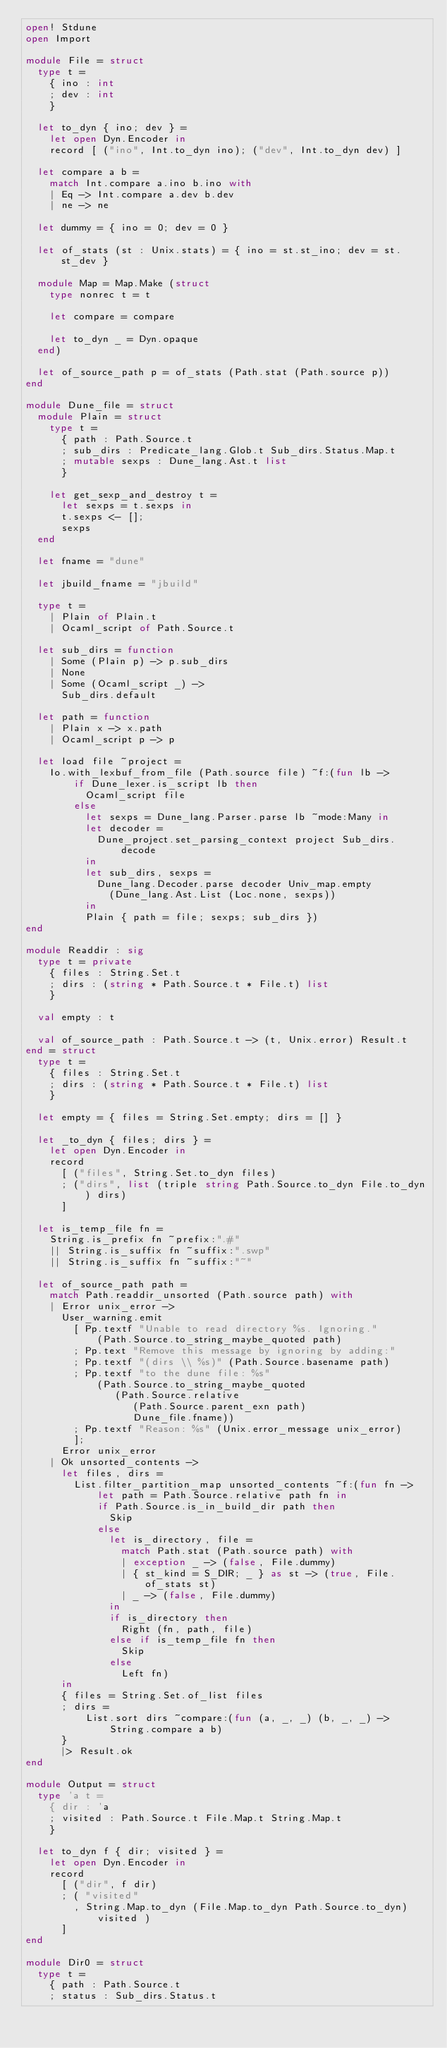<code> <loc_0><loc_0><loc_500><loc_500><_OCaml_>open! Stdune
open Import

module File = struct
  type t =
    { ino : int
    ; dev : int
    }

  let to_dyn { ino; dev } =
    let open Dyn.Encoder in
    record [ ("ino", Int.to_dyn ino); ("dev", Int.to_dyn dev) ]

  let compare a b =
    match Int.compare a.ino b.ino with
    | Eq -> Int.compare a.dev b.dev
    | ne -> ne

  let dummy = { ino = 0; dev = 0 }

  let of_stats (st : Unix.stats) = { ino = st.st_ino; dev = st.st_dev }

  module Map = Map.Make (struct
    type nonrec t = t

    let compare = compare

    let to_dyn _ = Dyn.opaque
  end)

  let of_source_path p = of_stats (Path.stat (Path.source p))
end

module Dune_file = struct
  module Plain = struct
    type t =
      { path : Path.Source.t
      ; sub_dirs : Predicate_lang.Glob.t Sub_dirs.Status.Map.t
      ; mutable sexps : Dune_lang.Ast.t list
      }

    let get_sexp_and_destroy t =
      let sexps = t.sexps in
      t.sexps <- [];
      sexps
  end

  let fname = "dune"

  let jbuild_fname = "jbuild"

  type t =
    | Plain of Plain.t
    | Ocaml_script of Path.Source.t

  let sub_dirs = function
    | Some (Plain p) -> p.sub_dirs
    | None
    | Some (Ocaml_script _) ->
      Sub_dirs.default

  let path = function
    | Plain x -> x.path
    | Ocaml_script p -> p

  let load file ~project =
    Io.with_lexbuf_from_file (Path.source file) ~f:(fun lb ->
        if Dune_lexer.is_script lb then
          Ocaml_script file
        else
          let sexps = Dune_lang.Parser.parse lb ~mode:Many in
          let decoder =
            Dune_project.set_parsing_context project Sub_dirs.decode
          in
          let sub_dirs, sexps =
            Dune_lang.Decoder.parse decoder Univ_map.empty
              (Dune_lang.Ast.List (Loc.none, sexps))
          in
          Plain { path = file; sexps; sub_dirs })
end

module Readdir : sig
  type t = private
    { files : String.Set.t
    ; dirs : (string * Path.Source.t * File.t) list
    }

  val empty : t

  val of_source_path : Path.Source.t -> (t, Unix.error) Result.t
end = struct
  type t =
    { files : String.Set.t
    ; dirs : (string * Path.Source.t * File.t) list
    }

  let empty = { files = String.Set.empty; dirs = [] }

  let _to_dyn { files; dirs } =
    let open Dyn.Encoder in
    record
      [ ("files", String.Set.to_dyn files)
      ; ("dirs", list (triple string Path.Source.to_dyn File.to_dyn) dirs)
      ]

  let is_temp_file fn =
    String.is_prefix fn ~prefix:".#"
    || String.is_suffix fn ~suffix:".swp"
    || String.is_suffix fn ~suffix:"~"

  let of_source_path path =
    match Path.readdir_unsorted (Path.source path) with
    | Error unix_error ->
      User_warning.emit
        [ Pp.textf "Unable to read directory %s. Ignoring."
            (Path.Source.to_string_maybe_quoted path)
        ; Pp.text "Remove this message by ignoring by adding:"
        ; Pp.textf "(dirs \\ %s)" (Path.Source.basename path)
        ; Pp.textf "to the dune file: %s"
            (Path.Source.to_string_maybe_quoted
               (Path.Source.relative
                  (Path.Source.parent_exn path)
                  Dune_file.fname))
        ; Pp.textf "Reason: %s" (Unix.error_message unix_error)
        ];
      Error unix_error
    | Ok unsorted_contents ->
      let files, dirs =
        List.filter_partition_map unsorted_contents ~f:(fun fn ->
            let path = Path.Source.relative path fn in
            if Path.Source.is_in_build_dir path then
              Skip
            else
              let is_directory, file =
                match Path.stat (Path.source path) with
                | exception _ -> (false, File.dummy)
                | { st_kind = S_DIR; _ } as st -> (true, File.of_stats st)
                | _ -> (false, File.dummy)
              in
              if is_directory then
                Right (fn, path, file)
              else if is_temp_file fn then
                Skip
              else
                Left fn)
      in
      { files = String.Set.of_list files
      ; dirs =
          List.sort dirs ~compare:(fun (a, _, _) (b, _, _) ->
              String.compare a b)
      }
      |> Result.ok
end

module Output = struct
  type 'a t =
    { dir : 'a
    ; visited : Path.Source.t File.Map.t String.Map.t
    }

  let to_dyn f { dir; visited } =
    let open Dyn.Encoder in
    record
      [ ("dir", f dir)
      ; ( "visited"
        , String.Map.to_dyn (File.Map.to_dyn Path.Source.to_dyn) visited )
      ]
end

module Dir0 = struct
  type t =
    { path : Path.Source.t
    ; status : Sub_dirs.Status.t</code> 